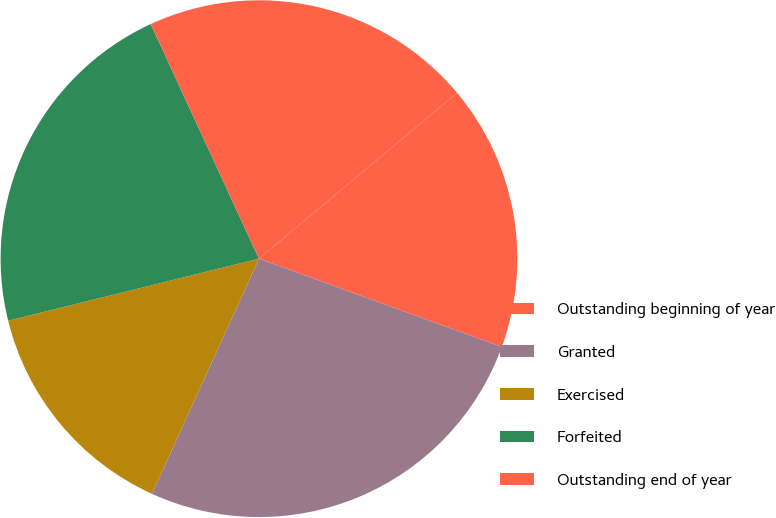Convert chart to OTSL. <chart><loc_0><loc_0><loc_500><loc_500><pie_chart><fcel>Outstanding beginning of year<fcel>Granted<fcel>Exercised<fcel>Forfeited<fcel>Outstanding end of year<nl><fcel>16.64%<fcel>26.25%<fcel>14.34%<fcel>21.98%<fcel>20.79%<nl></chart> 